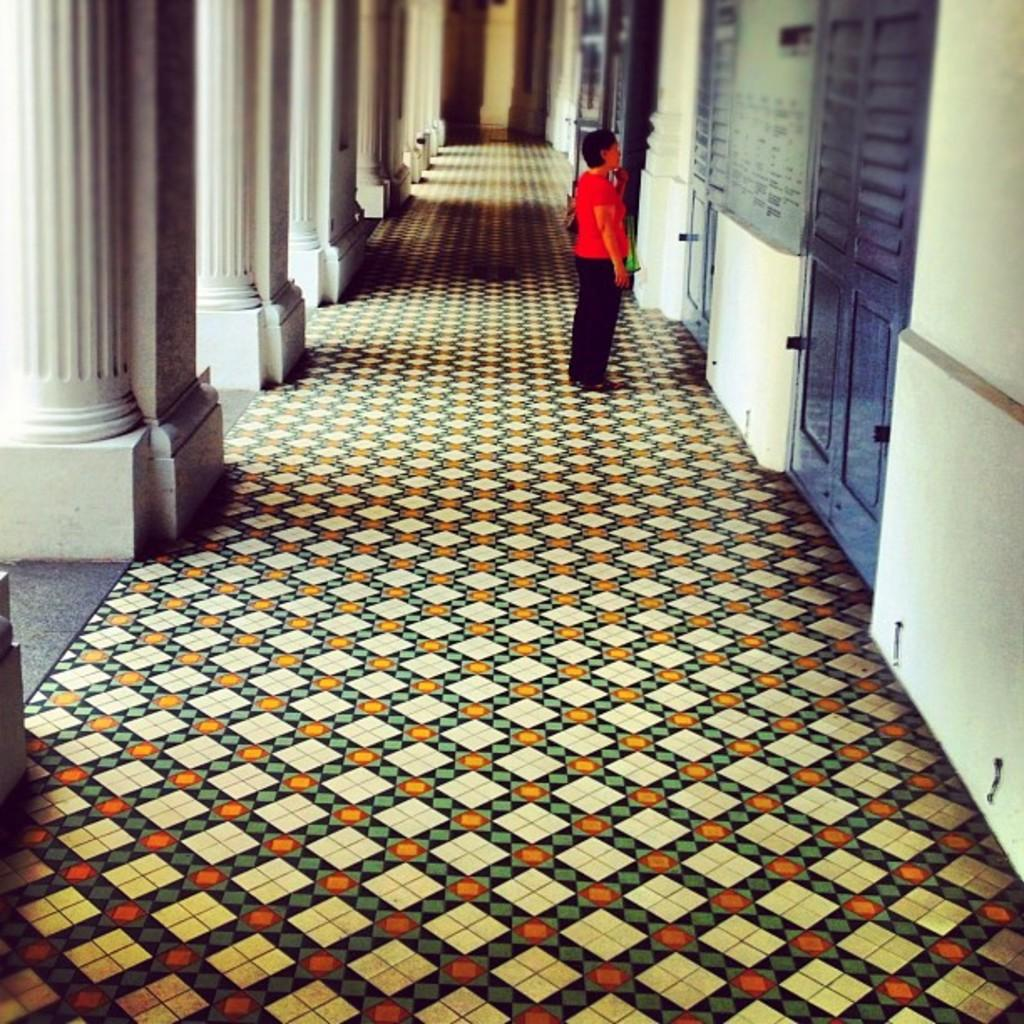What is the main subject of the image? There is a person standing in the image. Where is the person standing? The person is standing on the floor. What can be seen on the left side of the image? There are pillars on the left side of the image. What is written or displayed on the wall? There is a board with text on the wall. What can be seen on the right side of the image? There are doors on the right side of the image. What type of grip does the person have on the discovery in the image? There is no discovery present in the image, and therefore no grip can be observed. 